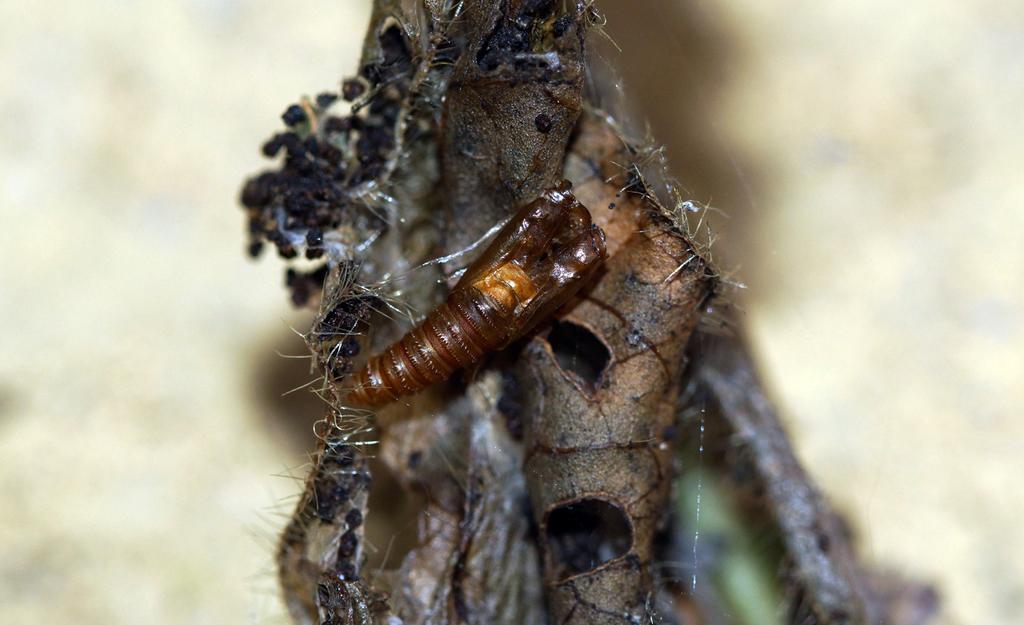Can you describe this image briefly? In the picture I can see insects on something. The background of the image is blurred. 